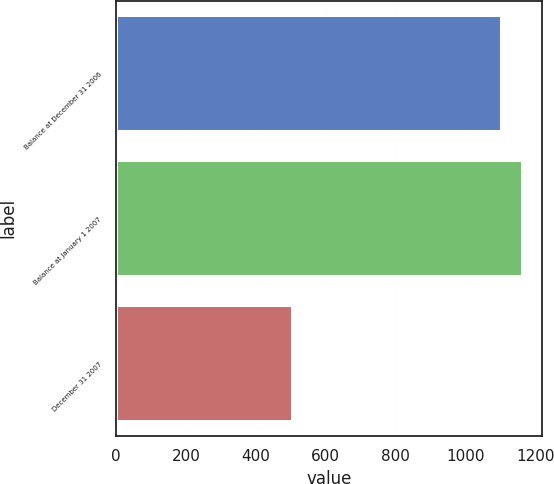Convert chart. <chart><loc_0><loc_0><loc_500><loc_500><bar_chart><fcel>Balance at December 31 2006<fcel>Balance at January 1 2007<fcel>December 31 2007<nl><fcel>1102<fcel>1161.9<fcel>503<nl></chart> 